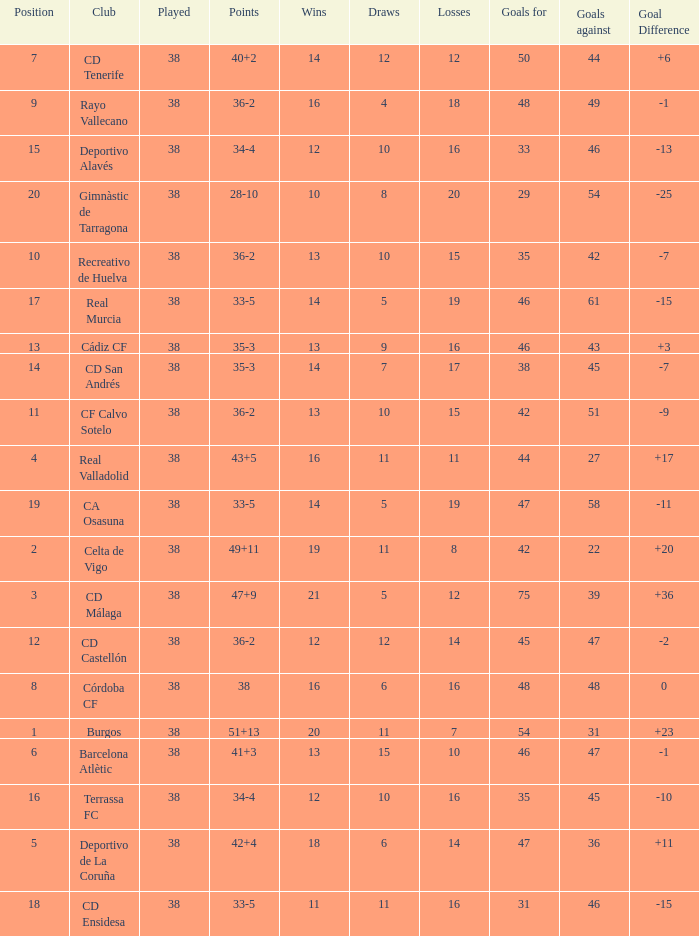Which position is the highest to have less than 54 goals, a loss of 7 and a goal difference higher than 23? None. 